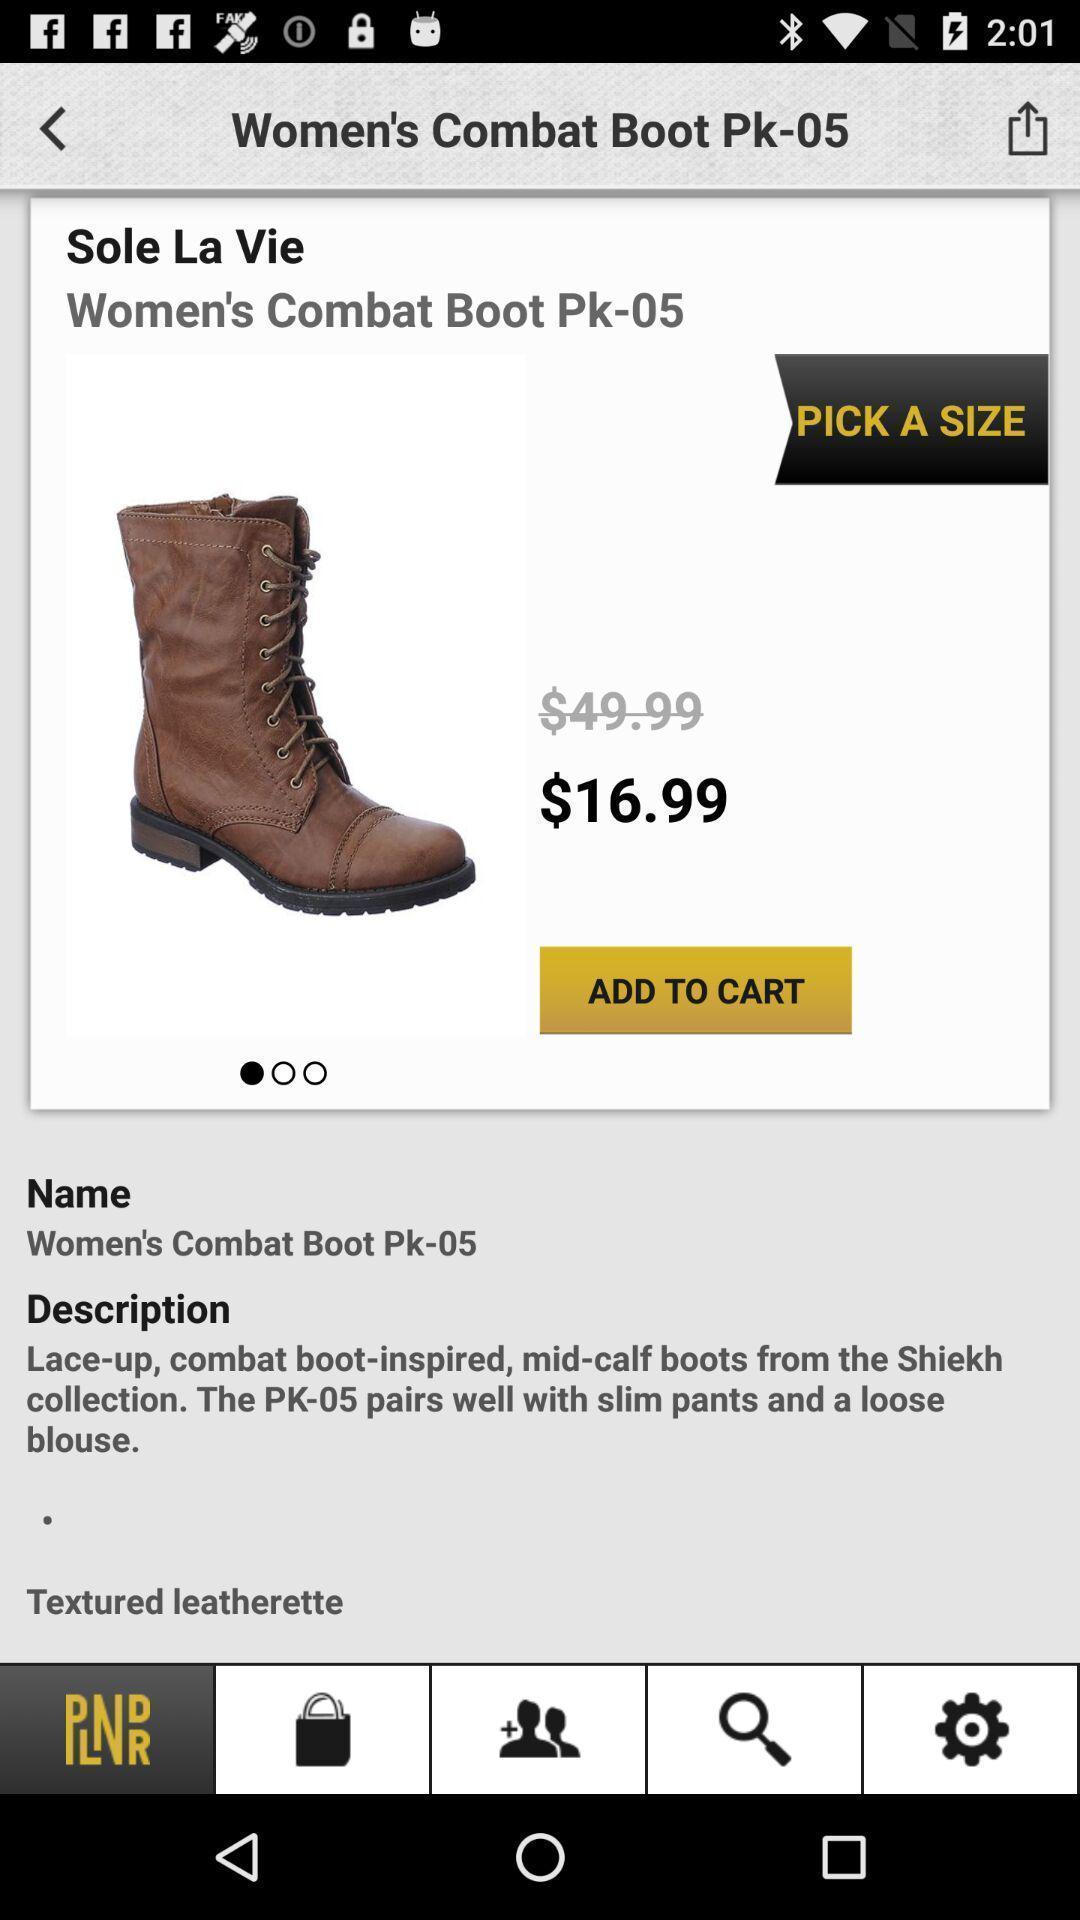Provide a detailed account of this screenshot. Page displaying the shoe with details in a shopping app. 